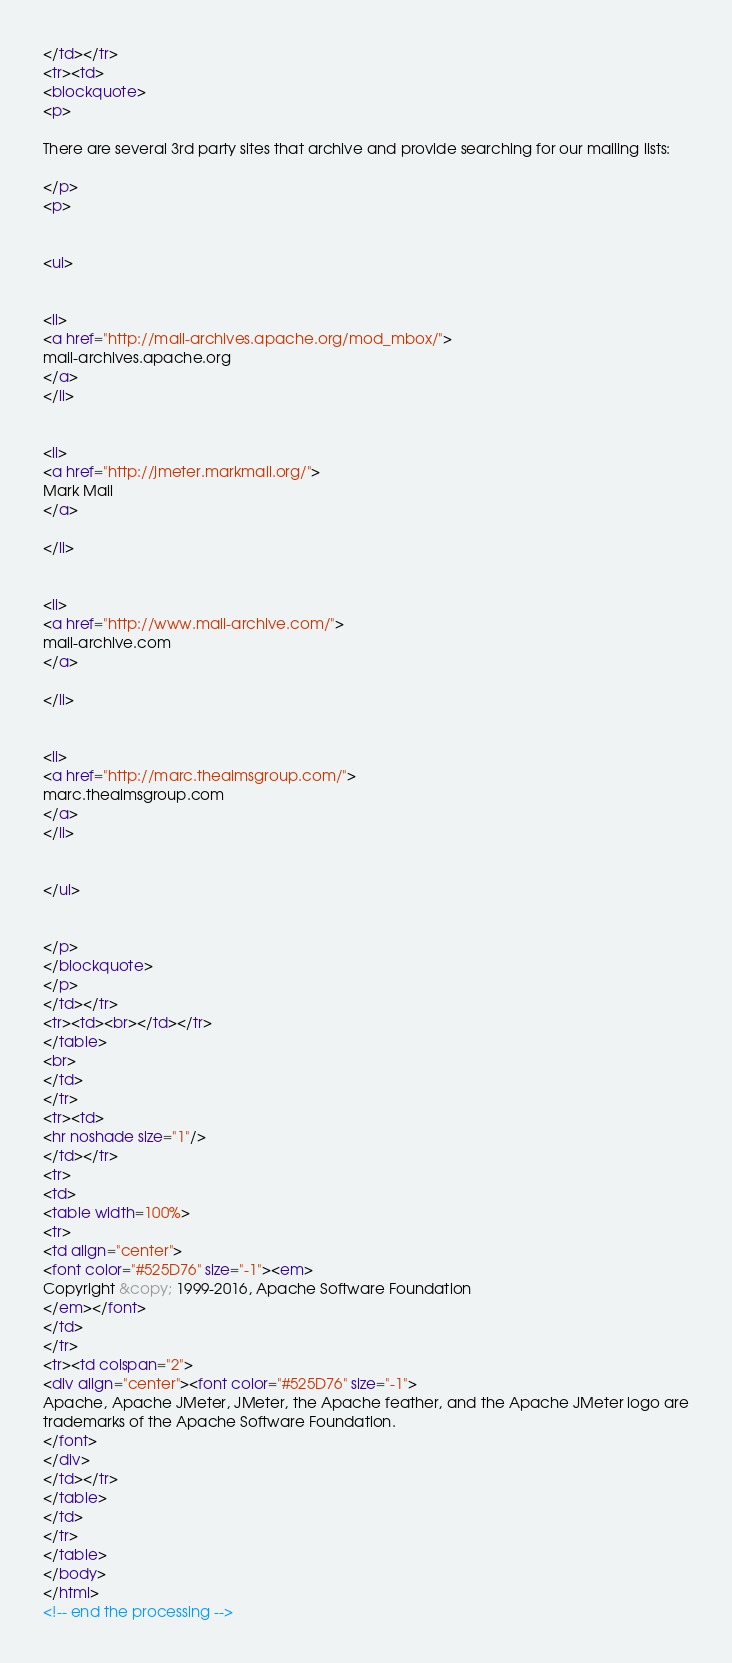<code> <loc_0><loc_0><loc_500><loc_500><_HTML_></td></tr>
<tr><td>
<blockquote>
<p>

There are several 3rd party sites that archive and provide searching for our mailing lists:

</p>
<p>


<ul>


<li>
<a href="http://mail-archives.apache.org/mod_mbox/">
mail-archives.apache.org
</a>
</li>


<li>
<a href="http://jmeter.markmail.org/">
Mark Mail
</a>
 
</li>


<li>
<a href="http://www.mail-archive.com/">
mail-archive.com
</a>
 
</li>


<li>
<a href="http://marc.theaimsgroup.com/">
marc.theaimsgroup.com
</a>
</li>


</ul>


</p>
</blockquote>
</p>
</td></tr>
<tr><td><br></td></tr>
</table>
<br>
</td>
</tr>
<tr><td>
<hr noshade size="1"/>
</td></tr>
<tr>
<td>
<table width=100%>
<tr>
<td align="center">
<font color="#525D76" size="-1"><em>
Copyright &copy; 1999-2016, Apache Software Foundation
</em></font>
</td>
</tr>
<tr><td colspan="2">
<div align="center"><font color="#525D76" size="-1">
Apache, Apache JMeter, JMeter, the Apache feather, and the Apache JMeter logo are
trademarks of the Apache Software Foundation.
</font>
</div>
</td></tr>
</table>
</td>
</tr>
</table>
</body>
</html>
<!-- end the processing -->









































</code> 